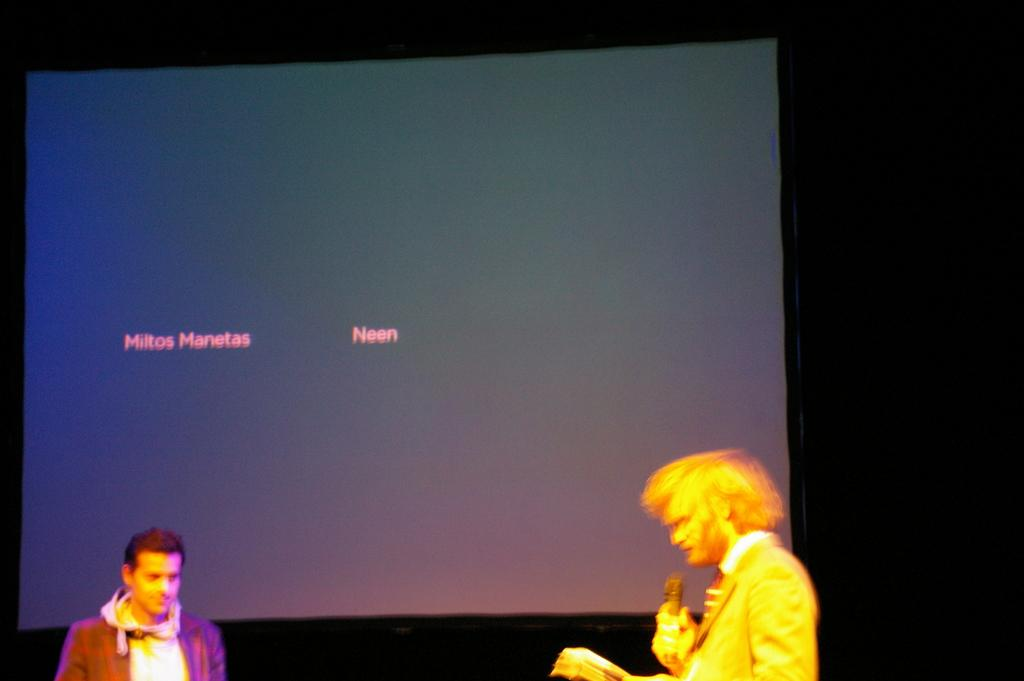How many people are in the image? There are two people in the image. Where are the people standing in the image? The people are standing on a path. What can be seen in the background of the image? There is a screen visible in the background of the image. What type of jeans is the rabbit wearing in the image? There is no rabbit present in the image, and therefore no one is wearing jeans. 